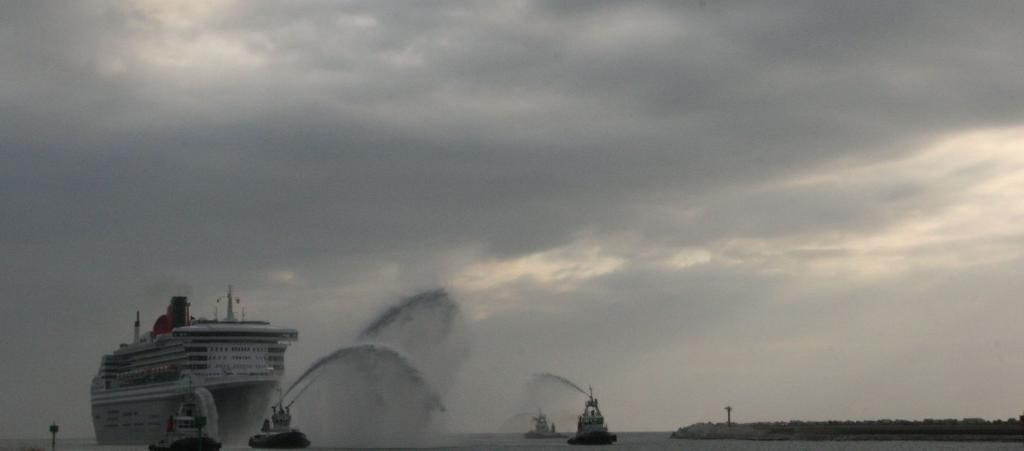What type of vehicles are present in the image? There are many boats and a ship in the image. Where are the boats and ship located? The boats and ship are on the water. What can be seen to the right of the image? There are people and plants visible to the right of the image. What is visible in the background of the image? There are clouds and the sky visible in the background of the image. What type of thrill can be experienced while sitting on the floor in the image? There is no floor present in the image, as it features boats and a ship on the water. 